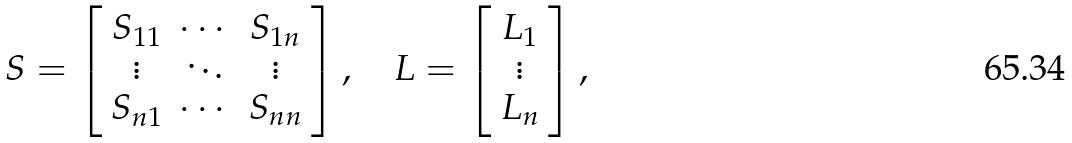Convert formula to latex. <formula><loc_0><loc_0><loc_500><loc_500>S = \left [ \begin{array} { c c c } S _ { 1 1 } & \cdots & S _ { 1 n } \\ \vdots & \ddots & \vdots \\ S _ { n 1 } & \cdots & S _ { n n } \end{array} \right ] , \quad L = \left [ \begin{array} { c } L _ { 1 } \\ \vdots \\ L _ { n } \end{array} \right ] ,</formula> 